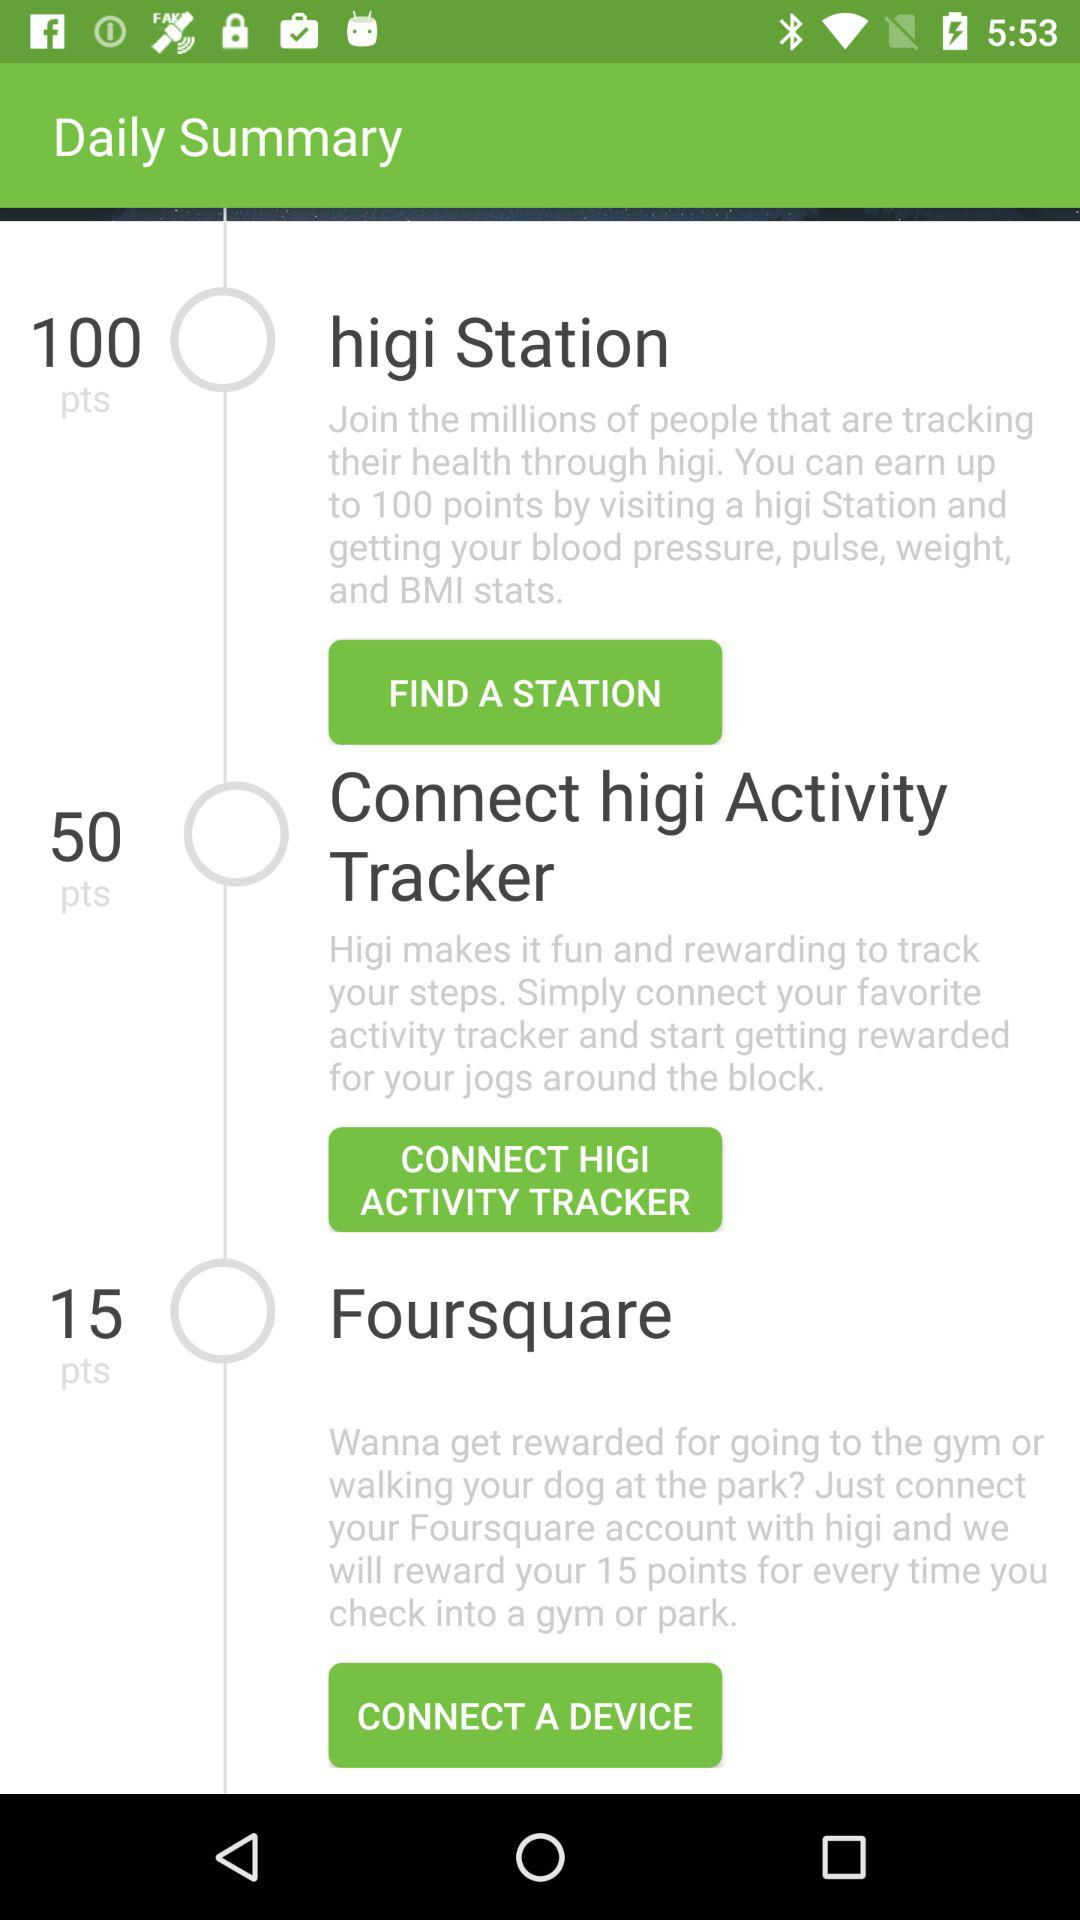How many points can we get by visiting a park or gym? By visiting a park or gym, you can get 15 points. 